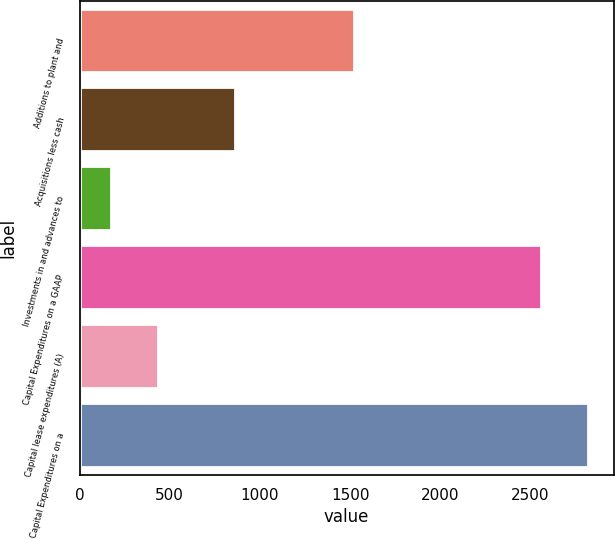<chart> <loc_0><loc_0><loc_500><loc_500><bar_chart><fcel>Additions to plant and<fcel>Acquisitions less cash<fcel>Investments in and advances to<fcel>Capital Expenditures on a GAAP<fcel>Capital lease expenditures (A)<fcel>Capital Expenditures on a<nl><fcel>1521<fcel>863.4<fcel>175.4<fcel>2559.8<fcel>435.69<fcel>2820.09<nl></chart> 